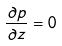Convert formula to latex. <formula><loc_0><loc_0><loc_500><loc_500>\frac { \partial p } { \partial z } = 0</formula> 